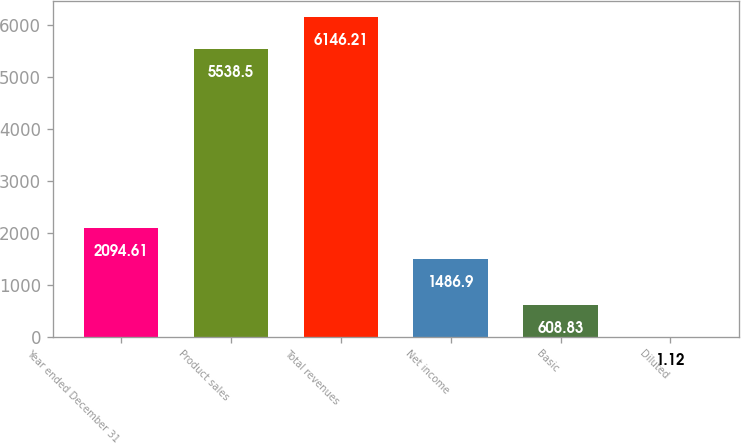<chart> <loc_0><loc_0><loc_500><loc_500><bar_chart><fcel>Year ended December 31<fcel>Product sales<fcel>Total revenues<fcel>Net income<fcel>Basic<fcel>Diluted<nl><fcel>2094.61<fcel>5538.5<fcel>6146.21<fcel>1486.9<fcel>608.83<fcel>1.12<nl></chart> 